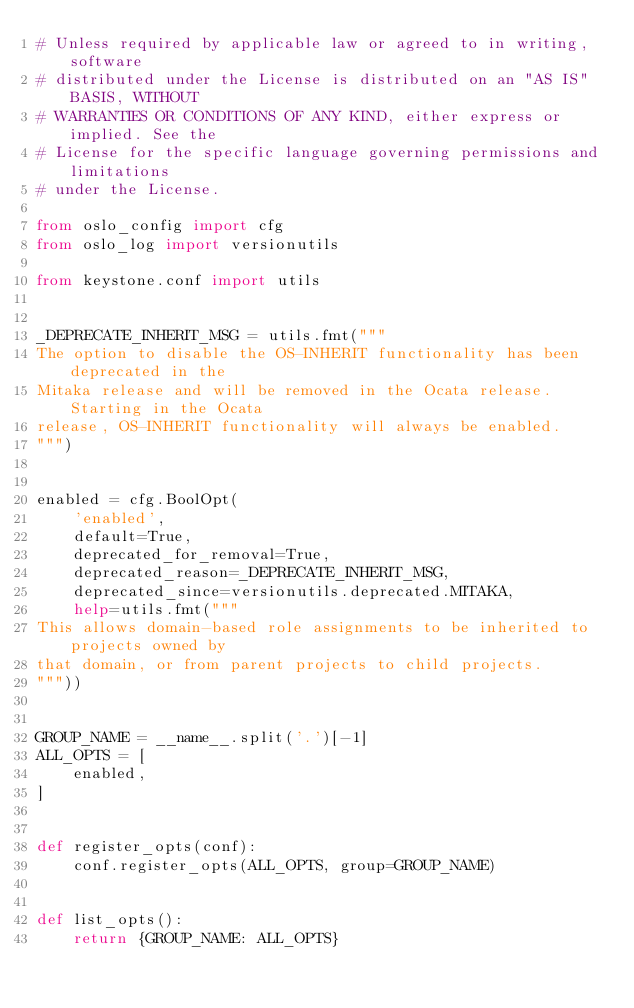<code> <loc_0><loc_0><loc_500><loc_500><_Python_># Unless required by applicable law or agreed to in writing, software
# distributed under the License is distributed on an "AS IS" BASIS, WITHOUT
# WARRANTIES OR CONDITIONS OF ANY KIND, either express or implied. See the
# License for the specific language governing permissions and limitations
# under the License.

from oslo_config import cfg
from oslo_log import versionutils

from keystone.conf import utils


_DEPRECATE_INHERIT_MSG = utils.fmt("""
The option to disable the OS-INHERIT functionality has been deprecated in the
Mitaka release and will be removed in the Ocata release. Starting in the Ocata
release, OS-INHERIT functionality will always be enabled.
""")


enabled = cfg.BoolOpt(
    'enabled',
    default=True,
    deprecated_for_removal=True,
    deprecated_reason=_DEPRECATE_INHERIT_MSG,
    deprecated_since=versionutils.deprecated.MITAKA,
    help=utils.fmt("""
This allows domain-based role assignments to be inherited to projects owned by
that domain, or from parent projects to child projects.
"""))


GROUP_NAME = __name__.split('.')[-1]
ALL_OPTS = [
    enabled,
]


def register_opts(conf):
    conf.register_opts(ALL_OPTS, group=GROUP_NAME)


def list_opts():
    return {GROUP_NAME: ALL_OPTS}
</code> 